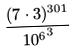Convert formula to latex. <formula><loc_0><loc_0><loc_500><loc_500>\frac { ( 7 \cdot 3 ) ^ { 3 0 1 } } { { 1 0 ^ { 6 } } ^ { 3 } }</formula> 